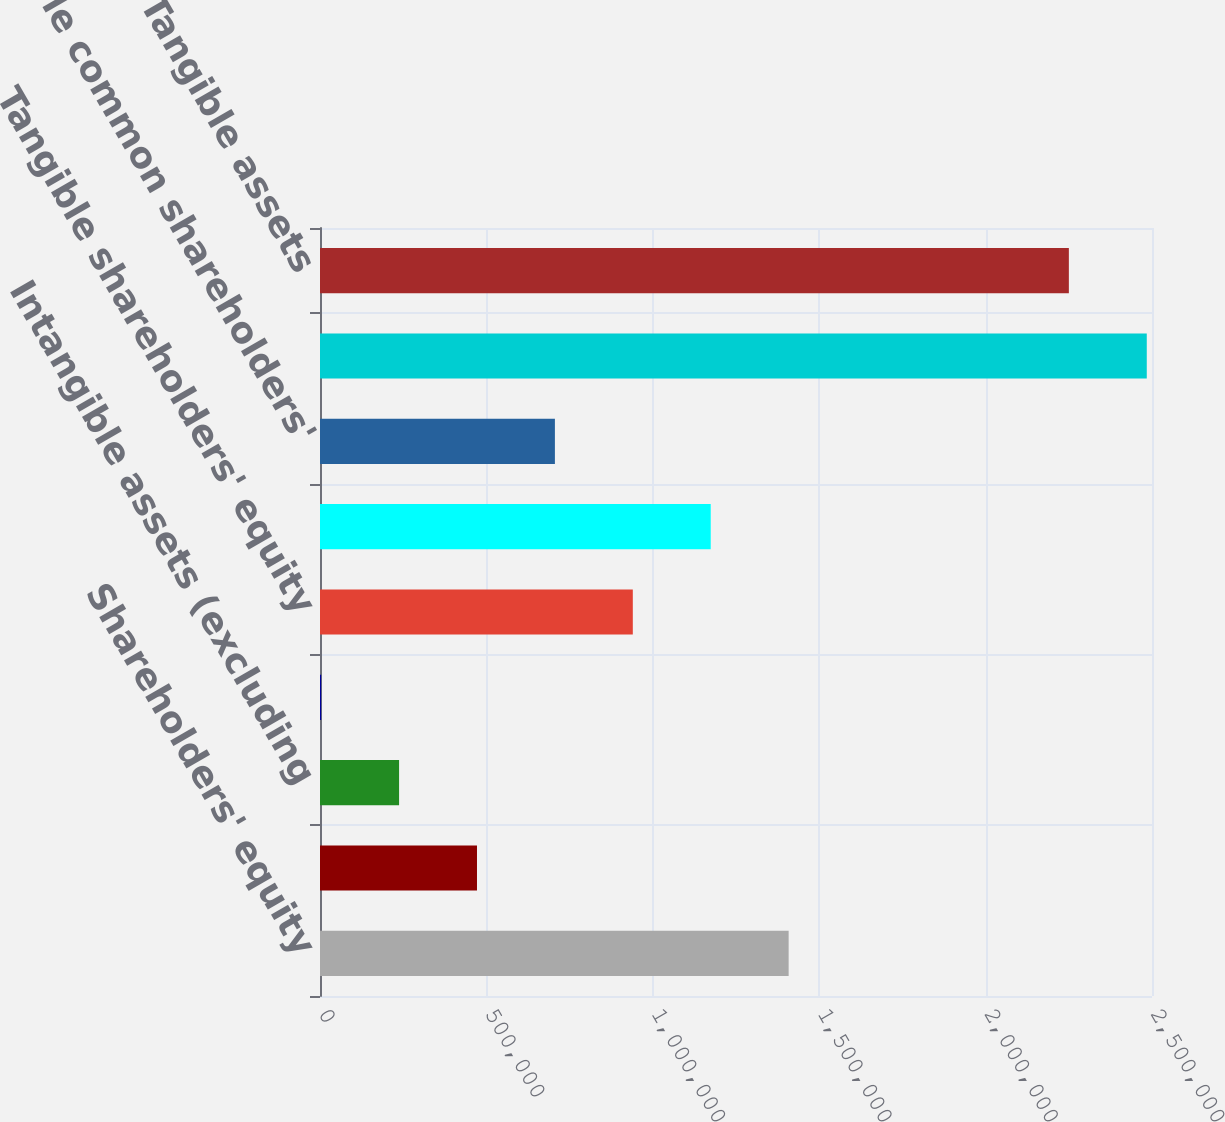<chart> <loc_0><loc_0><loc_500><loc_500><bar_chart><fcel>Shareholders' equity<fcel>Goodwill<fcel>Intangible assets (excluding<fcel>Related deferred tax<fcel>Tangible shareholders' equity<fcel>Common shareholders' equity<fcel>Tangible common shareholders'<fcel>Assets<fcel>Tangible assets<nl><fcel>1.40818e+06<fcel>471724<fcel>237611<fcel>3497<fcel>939952<fcel>1.17407e+06<fcel>705838<fcel>2.48429e+06<fcel>2.25018e+06<nl></chart> 